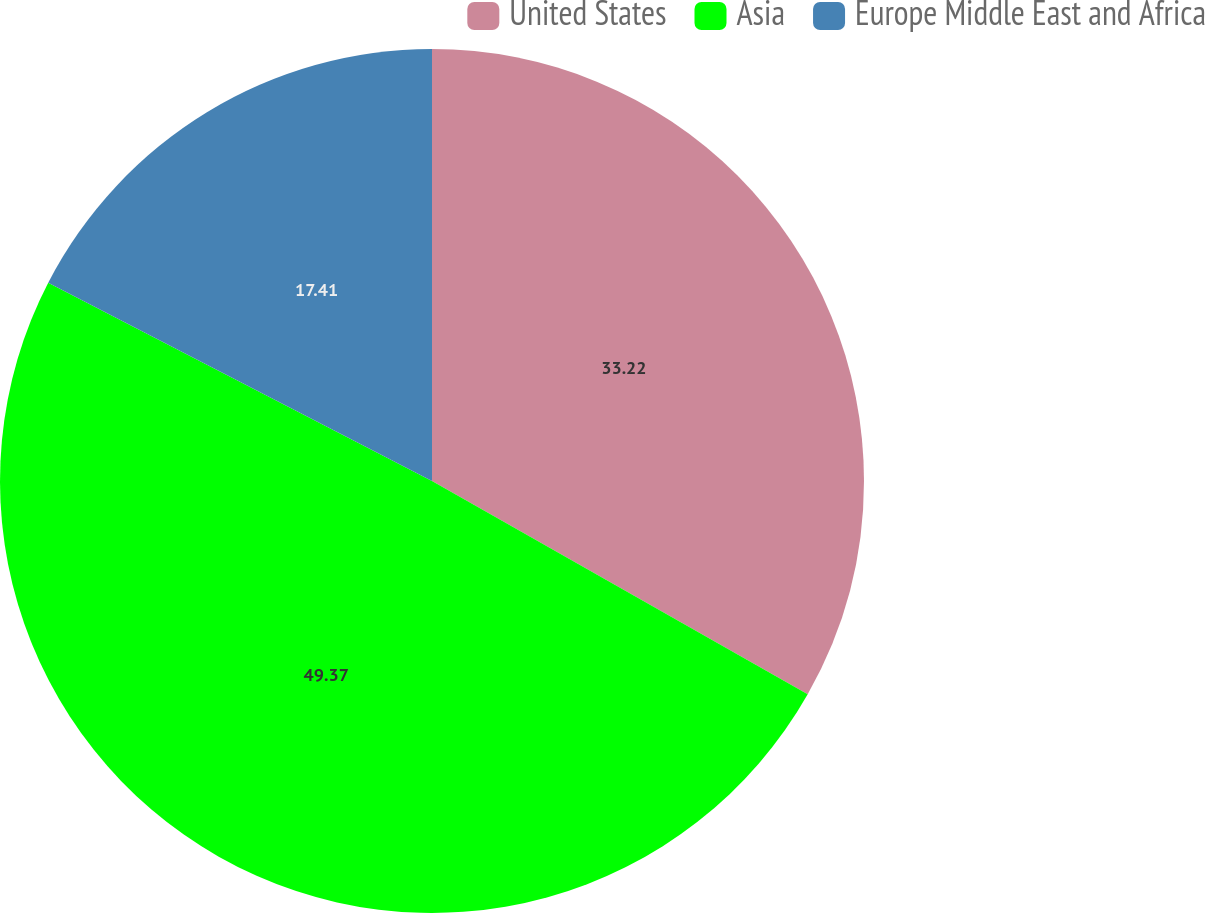<chart> <loc_0><loc_0><loc_500><loc_500><pie_chart><fcel>United States<fcel>Asia<fcel>Europe Middle East and Africa<nl><fcel>33.22%<fcel>49.38%<fcel>17.41%<nl></chart> 